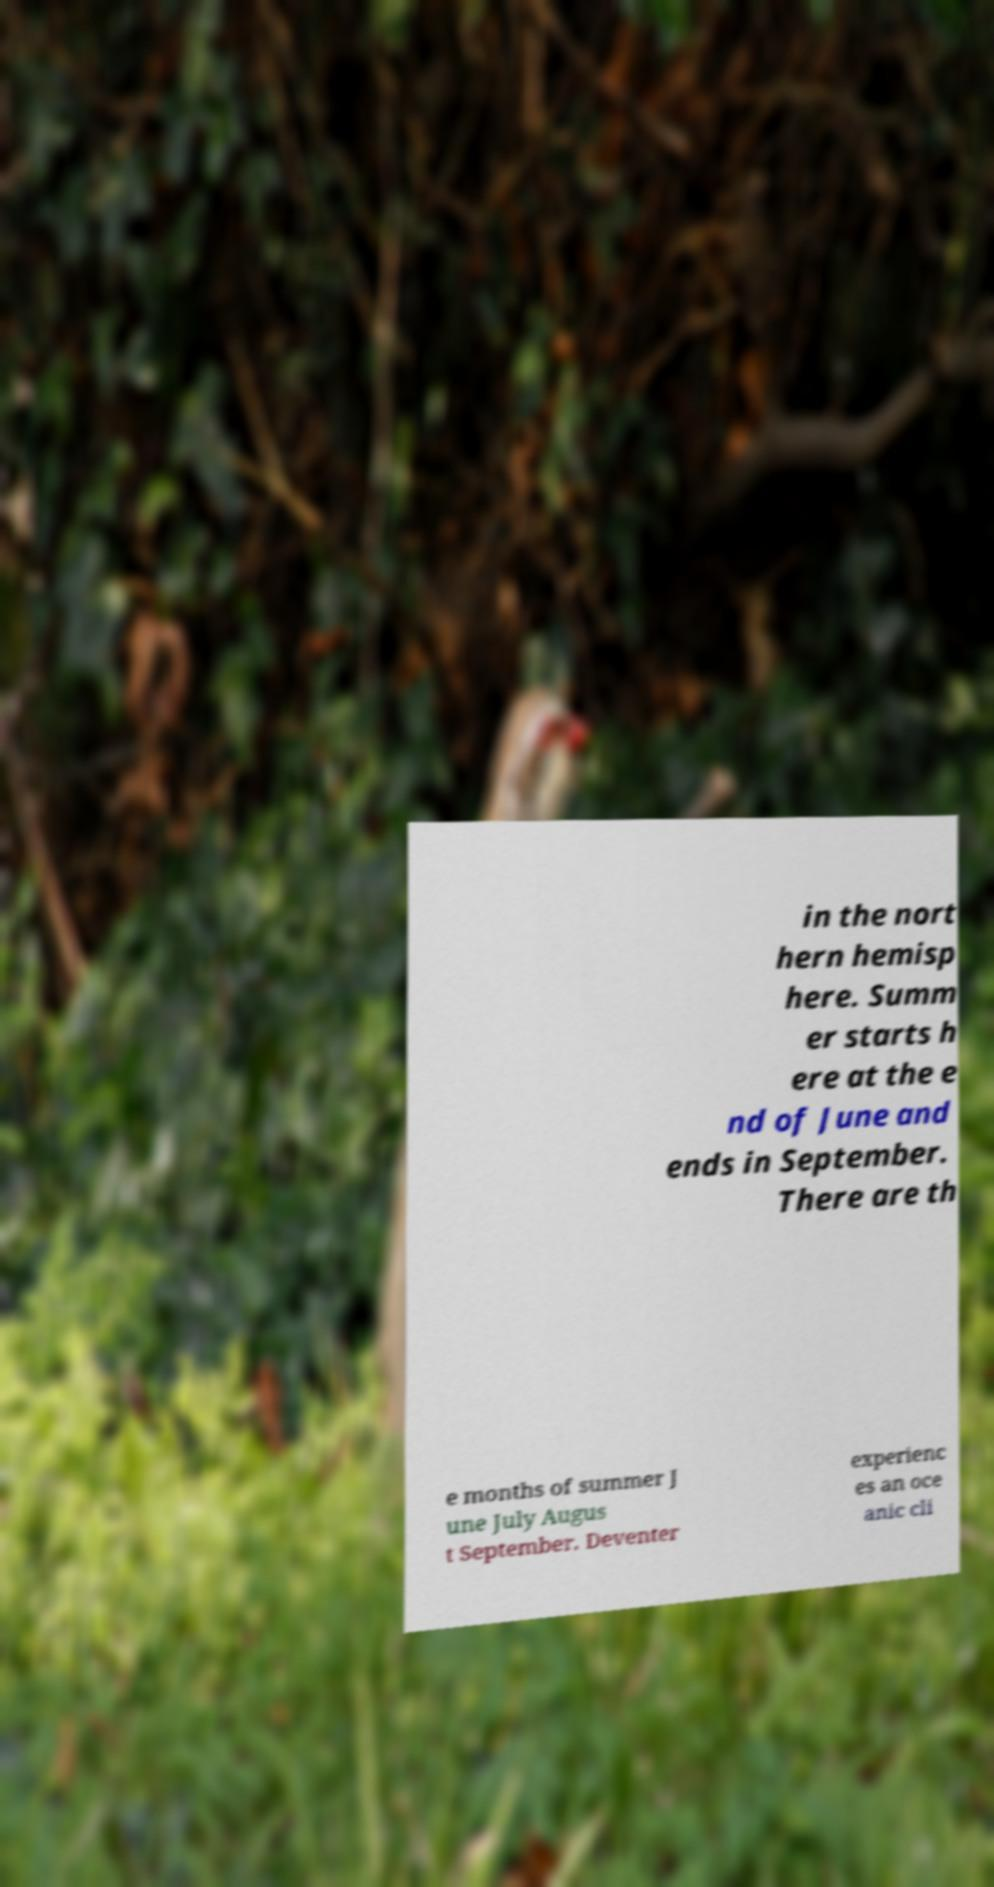For documentation purposes, I need the text within this image transcribed. Could you provide that? in the nort hern hemisp here. Summ er starts h ere at the e nd of June and ends in September. There are th e months of summer J une July Augus t September. Deventer experienc es an oce anic cli 